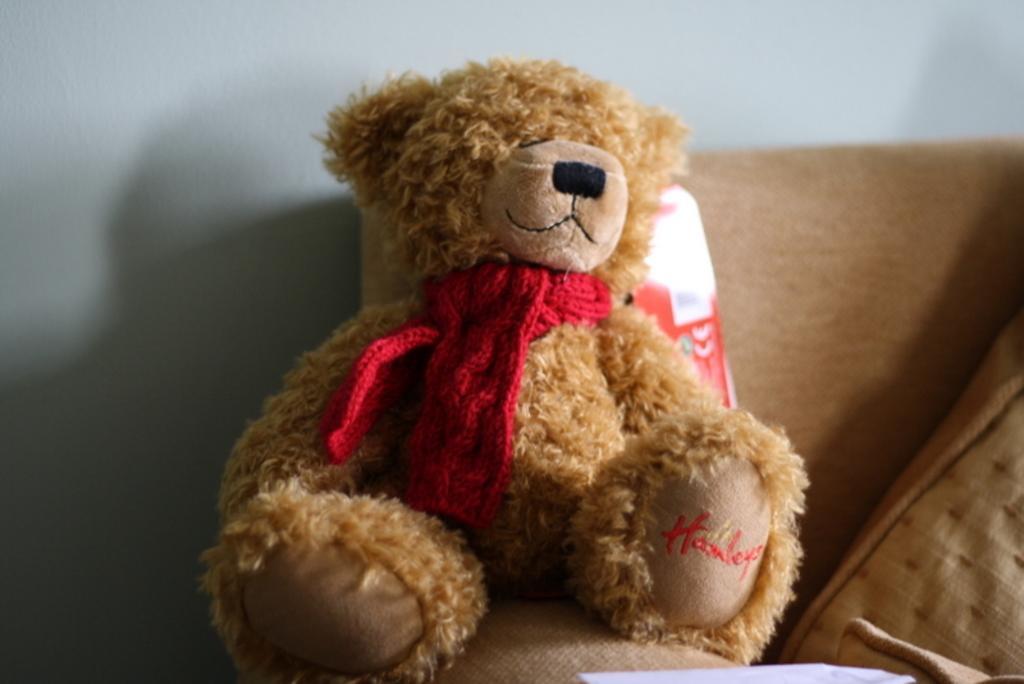In one or two sentences, can you explain what this image depicts? It is a teddy bear in brown color and this is the sofa in this image. 